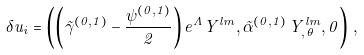Convert formula to latex. <formula><loc_0><loc_0><loc_500><loc_500>\delta u _ { i } = \left ( \left ( \tilde { \gamma } ^ { ( 0 , 1 ) } - \frac { \psi ^ { ( 0 , 1 ) } } { 2 } \right ) e ^ { \Lambda } Y ^ { l m } , \tilde { \alpha } ^ { ( 0 , 1 ) } \, Y ^ { l m } _ { , \, \theta } , 0 \right ) \, ,</formula> 